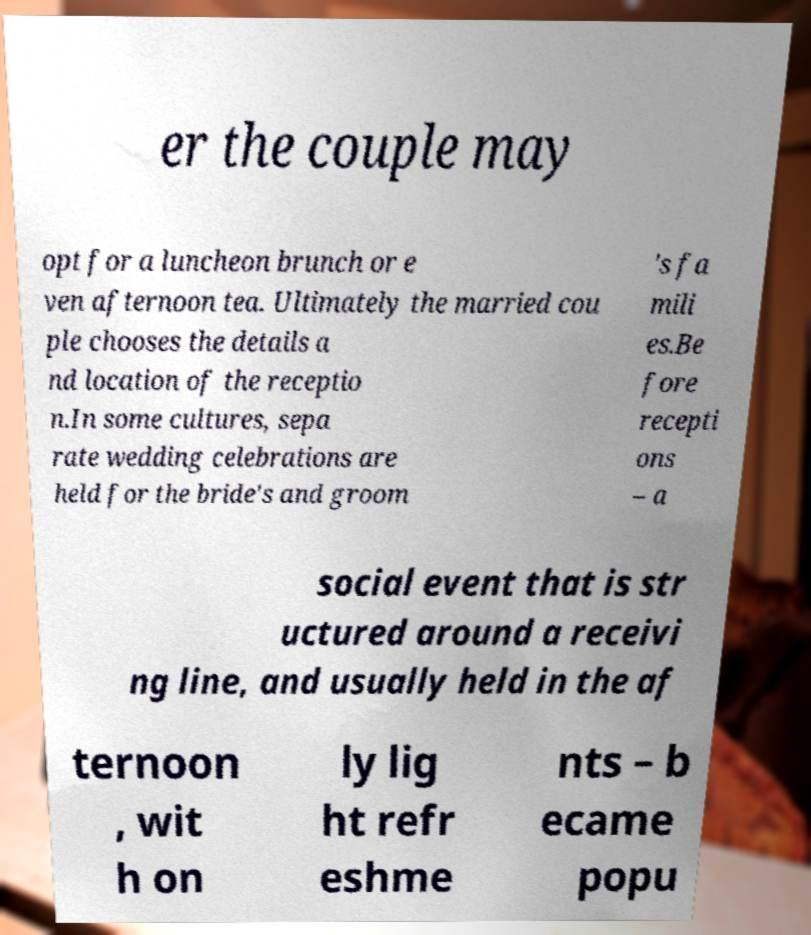I need the written content from this picture converted into text. Can you do that? er the couple may opt for a luncheon brunch or e ven afternoon tea. Ultimately the married cou ple chooses the details a nd location of the receptio n.In some cultures, sepa rate wedding celebrations are held for the bride's and groom 's fa mili es.Be fore recepti ons – a social event that is str uctured around a receivi ng line, and usually held in the af ternoon , wit h on ly lig ht refr eshme nts – b ecame popu 